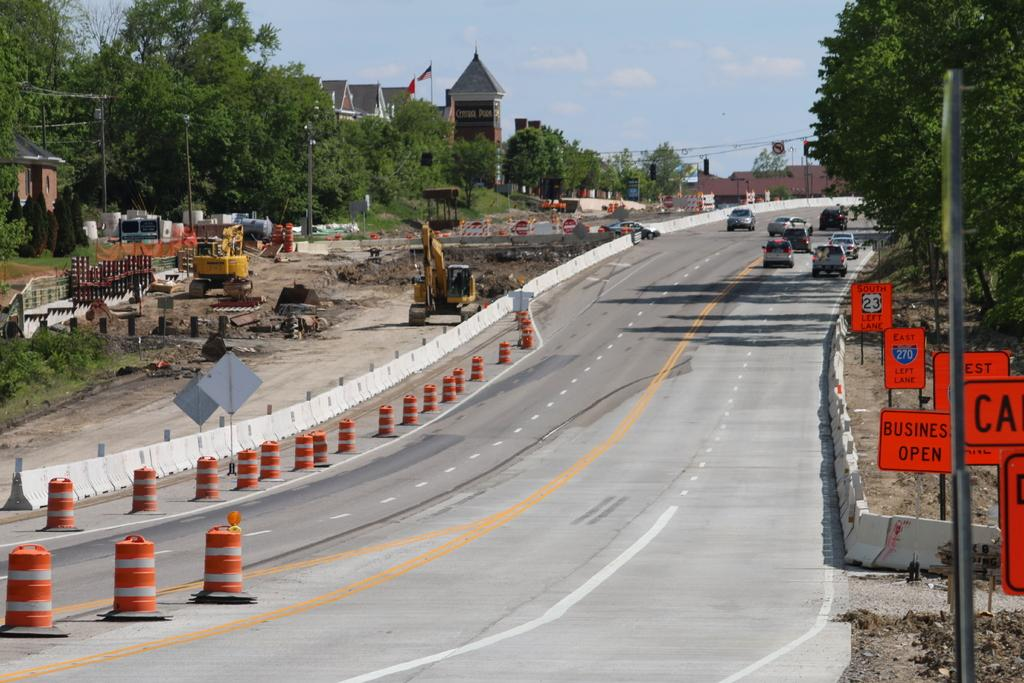<image>
Provide a brief description of the given image. Street with a sign which says Business open in orange. 